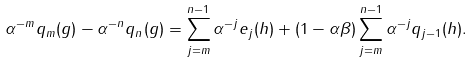Convert formula to latex. <formula><loc_0><loc_0><loc_500><loc_500>\alpha ^ { - m } q _ { m } ( g ) - \alpha ^ { - n } q _ { n } ( g ) = \sum _ { j = m } ^ { n - 1 } \alpha ^ { - j } e _ { j } ( h ) + ( 1 - \alpha \beta ) \sum _ { j = m } ^ { n - 1 } \alpha ^ { - j } q _ { j - 1 } ( h ) .</formula> 